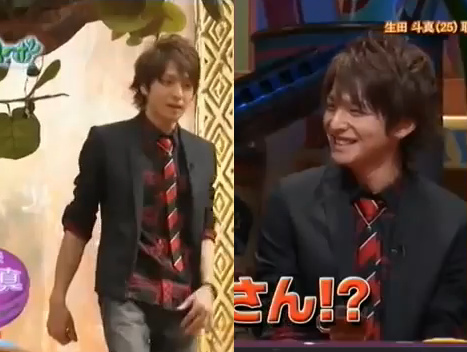Why might the man on the left be wearing a tie? The man on the left might be wearing a tie because the event demands a formal dress code. Wearing a tie often indicates professionalism, respect for the occasion, or an effort to present oneself neatly in a public setting. 